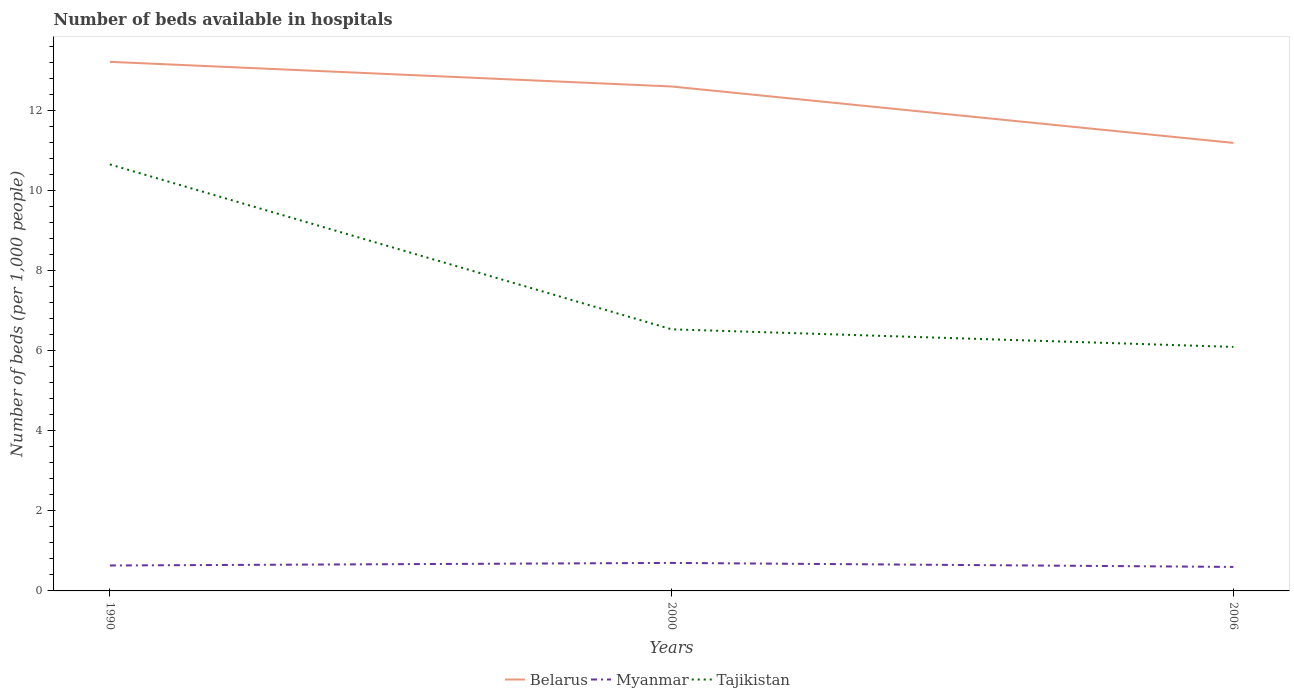How many different coloured lines are there?
Keep it short and to the point. 3. Does the line corresponding to Myanmar intersect with the line corresponding to Belarus?
Offer a very short reply. No. What is the total number of beds in the hospiatls of in Belarus in the graph?
Offer a very short reply. 0.62. What is the difference between the highest and the second highest number of beds in the hospiatls of in Tajikistan?
Provide a short and direct response. 4.56. How many lines are there?
Your answer should be compact. 3. How many years are there in the graph?
Offer a terse response. 3. What is the difference between two consecutive major ticks on the Y-axis?
Offer a very short reply. 2. Does the graph contain any zero values?
Offer a terse response. No. Does the graph contain grids?
Offer a terse response. No. Where does the legend appear in the graph?
Provide a succinct answer. Bottom center. What is the title of the graph?
Your answer should be very brief. Number of beds available in hospitals. What is the label or title of the Y-axis?
Give a very brief answer. Number of beds (per 1,0 people). What is the Number of beds (per 1,000 people) of Belarus in 1990?
Provide a succinct answer. 13.23. What is the Number of beds (per 1,000 people) in Myanmar in 1990?
Provide a succinct answer. 0.64. What is the Number of beds (per 1,000 people) in Tajikistan in 1990?
Give a very brief answer. 10.66. What is the Number of beds (per 1,000 people) of Belarus in 2000?
Provide a succinct answer. 12.61. What is the Number of beds (per 1,000 people) in Myanmar in 2000?
Ensure brevity in your answer.  0.7. What is the Number of beds (per 1,000 people) in Tajikistan in 2000?
Your answer should be very brief. 6.54. What is the Number of beds (per 1,000 people) of Myanmar in 2006?
Offer a terse response. 0.6. Across all years, what is the maximum Number of beds (per 1,000 people) in Belarus?
Your answer should be very brief. 13.23. Across all years, what is the maximum Number of beds (per 1,000 people) in Tajikistan?
Provide a short and direct response. 10.66. Across all years, what is the minimum Number of beds (per 1,000 people) of Belarus?
Provide a short and direct response. 11.2. Across all years, what is the minimum Number of beds (per 1,000 people) in Tajikistan?
Ensure brevity in your answer.  6.1. What is the total Number of beds (per 1,000 people) of Belarus in the graph?
Your answer should be very brief. 37.04. What is the total Number of beds (per 1,000 people) in Myanmar in the graph?
Your answer should be compact. 1.94. What is the total Number of beds (per 1,000 people) of Tajikistan in the graph?
Provide a short and direct response. 23.3. What is the difference between the Number of beds (per 1,000 people) in Belarus in 1990 and that in 2000?
Provide a succinct answer. 0.62. What is the difference between the Number of beds (per 1,000 people) in Myanmar in 1990 and that in 2000?
Ensure brevity in your answer.  -0.06. What is the difference between the Number of beds (per 1,000 people) of Tajikistan in 1990 and that in 2000?
Provide a succinct answer. 4.12. What is the difference between the Number of beds (per 1,000 people) in Belarus in 1990 and that in 2006?
Your response must be concise. 2.03. What is the difference between the Number of beds (per 1,000 people) in Myanmar in 1990 and that in 2006?
Keep it short and to the point. 0.04. What is the difference between the Number of beds (per 1,000 people) of Tajikistan in 1990 and that in 2006?
Provide a short and direct response. 4.56. What is the difference between the Number of beds (per 1,000 people) in Belarus in 2000 and that in 2006?
Your response must be concise. 1.41. What is the difference between the Number of beds (per 1,000 people) in Tajikistan in 2000 and that in 2006?
Keep it short and to the point. 0.44. What is the difference between the Number of beds (per 1,000 people) in Belarus in 1990 and the Number of beds (per 1,000 people) in Myanmar in 2000?
Your answer should be very brief. 12.53. What is the difference between the Number of beds (per 1,000 people) in Belarus in 1990 and the Number of beds (per 1,000 people) in Tajikistan in 2000?
Keep it short and to the point. 6.69. What is the difference between the Number of beds (per 1,000 people) in Myanmar in 1990 and the Number of beds (per 1,000 people) in Tajikistan in 2000?
Keep it short and to the point. -5.9. What is the difference between the Number of beds (per 1,000 people) in Belarus in 1990 and the Number of beds (per 1,000 people) in Myanmar in 2006?
Offer a very short reply. 12.63. What is the difference between the Number of beds (per 1,000 people) in Belarus in 1990 and the Number of beds (per 1,000 people) in Tajikistan in 2006?
Make the answer very short. 7.13. What is the difference between the Number of beds (per 1,000 people) of Myanmar in 1990 and the Number of beds (per 1,000 people) of Tajikistan in 2006?
Make the answer very short. -5.46. What is the difference between the Number of beds (per 1,000 people) in Belarus in 2000 and the Number of beds (per 1,000 people) in Myanmar in 2006?
Your response must be concise. 12.01. What is the difference between the Number of beds (per 1,000 people) of Belarus in 2000 and the Number of beds (per 1,000 people) of Tajikistan in 2006?
Give a very brief answer. 6.51. What is the average Number of beds (per 1,000 people) in Belarus per year?
Keep it short and to the point. 12.35. What is the average Number of beds (per 1,000 people) in Myanmar per year?
Your answer should be very brief. 0.65. What is the average Number of beds (per 1,000 people) of Tajikistan per year?
Provide a succinct answer. 7.77. In the year 1990, what is the difference between the Number of beds (per 1,000 people) of Belarus and Number of beds (per 1,000 people) of Myanmar?
Keep it short and to the point. 12.59. In the year 1990, what is the difference between the Number of beds (per 1,000 people) of Belarus and Number of beds (per 1,000 people) of Tajikistan?
Offer a very short reply. 2.56. In the year 1990, what is the difference between the Number of beds (per 1,000 people) of Myanmar and Number of beds (per 1,000 people) of Tajikistan?
Offer a terse response. -10.03. In the year 2000, what is the difference between the Number of beds (per 1,000 people) in Belarus and Number of beds (per 1,000 people) in Myanmar?
Provide a succinct answer. 11.91. In the year 2000, what is the difference between the Number of beds (per 1,000 people) of Belarus and Number of beds (per 1,000 people) of Tajikistan?
Ensure brevity in your answer.  6.07. In the year 2000, what is the difference between the Number of beds (per 1,000 people) in Myanmar and Number of beds (per 1,000 people) in Tajikistan?
Offer a very short reply. -5.84. In the year 2006, what is the difference between the Number of beds (per 1,000 people) in Belarus and Number of beds (per 1,000 people) in Myanmar?
Offer a terse response. 10.6. In the year 2006, what is the difference between the Number of beds (per 1,000 people) in Belarus and Number of beds (per 1,000 people) in Tajikistan?
Provide a succinct answer. 5.1. In the year 2006, what is the difference between the Number of beds (per 1,000 people) of Myanmar and Number of beds (per 1,000 people) of Tajikistan?
Ensure brevity in your answer.  -5.5. What is the ratio of the Number of beds (per 1,000 people) in Belarus in 1990 to that in 2000?
Make the answer very short. 1.05. What is the ratio of the Number of beds (per 1,000 people) of Myanmar in 1990 to that in 2000?
Keep it short and to the point. 0.91. What is the ratio of the Number of beds (per 1,000 people) of Tajikistan in 1990 to that in 2000?
Ensure brevity in your answer.  1.63. What is the ratio of the Number of beds (per 1,000 people) in Belarus in 1990 to that in 2006?
Ensure brevity in your answer.  1.18. What is the ratio of the Number of beds (per 1,000 people) of Myanmar in 1990 to that in 2006?
Provide a succinct answer. 1.06. What is the ratio of the Number of beds (per 1,000 people) of Tajikistan in 1990 to that in 2006?
Your answer should be very brief. 1.75. What is the ratio of the Number of beds (per 1,000 people) of Belarus in 2000 to that in 2006?
Give a very brief answer. 1.13. What is the ratio of the Number of beds (per 1,000 people) in Myanmar in 2000 to that in 2006?
Offer a terse response. 1.17. What is the ratio of the Number of beds (per 1,000 people) in Tajikistan in 2000 to that in 2006?
Keep it short and to the point. 1.07. What is the difference between the highest and the second highest Number of beds (per 1,000 people) in Belarus?
Offer a very short reply. 0.62. What is the difference between the highest and the second highest Number of beds (per 1,000 people) in Myanmar?
Give a very brief answer. 0.06. What is the difference between the highest and the second highest Number of beds (per 1,000 people) of Tajikistan?
Offer a terse response. 4.12. What is the difference between the highest and the lowest Number of beds (per 1,000 people) in Belarus?
Give a very brief answer. 2.03. What is the difference between the highest and the lowest Number of beds (per 1,000 people) in Myanmar?
Ensure brevity in your answer.  0.1. What is the difference between the highest and the lowest Number of beds (per 1,000 people) of Tajikistan?
Your answer should be very brief. 4.56. 